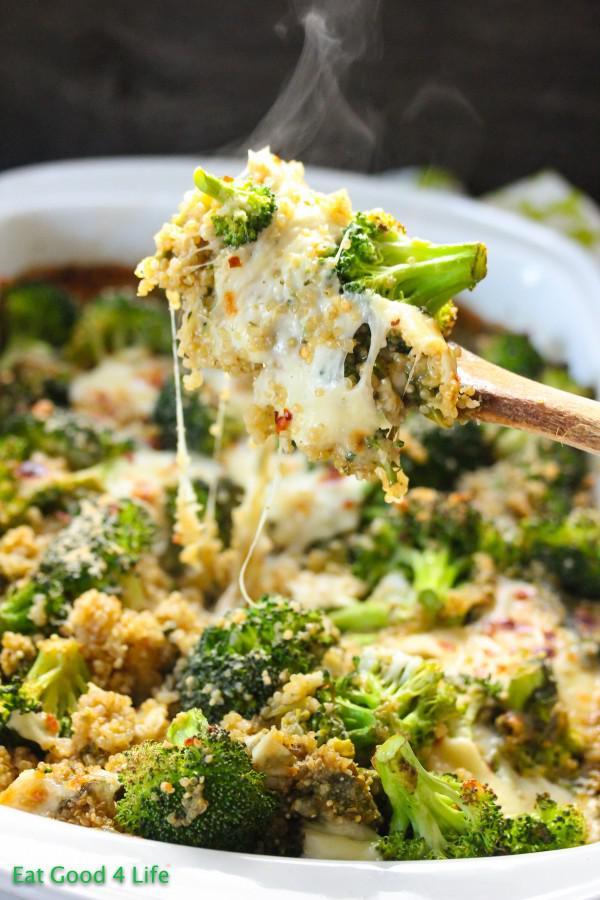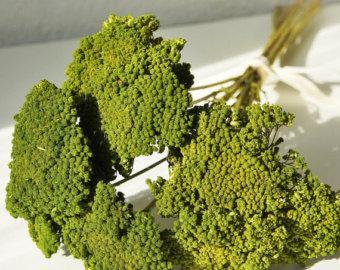The first image is the image on the left, the second image is the image on the right. For the images shown, is this caption "The image on the left contains cooked food." true? Answer yes or no. Yes. 